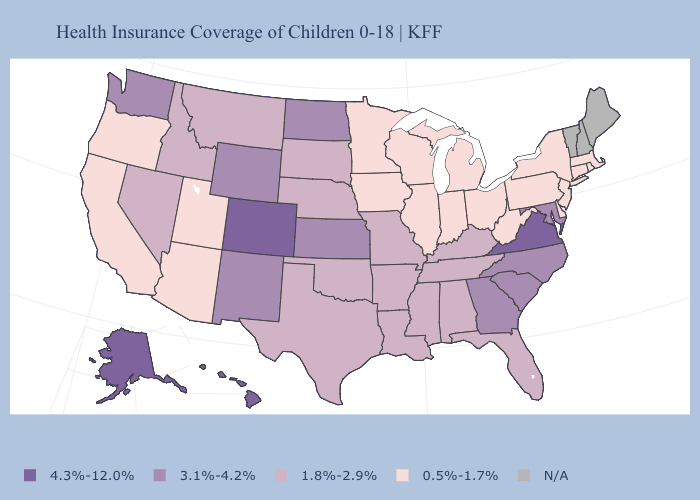Name the states that have a value in the range N/A?
Write a very short answer. Maine, New Hampshire, Vermont. What is the value of West Virginia?
Concise answer only. 0.5%-1.7%. What is the value of Arkansas?
Keep it brief. 1.8%-2.9%. What is the lowest value in the USA?
Give a very brief answer. 0.5%-1.7%. What is the value of Indiana?
Quick response, please. 0.5%-1.7%. What is the value of Ohio?
Write a very short answer. 0.5%-1.7%. Name the states that have a value in the range 1.8%-2.9%?
Answer briefly. Alabama, Arkansas, Florida, Idaho, Kentucky, Louisiana, Mississippi, Missouri, Montana, Nebraska, Nevada, Oklahoma, South Dakota, Tennessee, Texas. Is the legend a continuous bar?
Answer briefly. No. Name the states that have a value in the range N/A?
Be succinct. Maine, New Hampshire, Vermont. Name the states that have a value in the range 3.1%-4.2%?
Keep it brief. Georgia, Kansas, Maryland, New Mexico, North Carolina, North Dakota, South Carolina, Washington, Wyoming. Name the states that have a value in the range N/A?
Short answer required. Maine, New Hampshire, Vermont. What is the value of Montana?
Quick response, please. 1.8%-2.9%. 